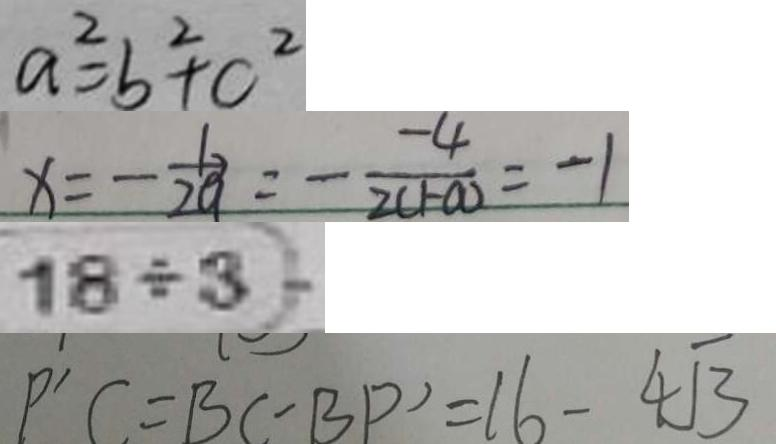<formula> <loc_0><loc_0><loc_500><loc_500>a ^ { 2 } = b ^ { 2 } + c ^ { 2 } 
 x = - \frac { b } { 2 a } = - \frac { - 4 } { 2 ( 1 - a ) } = - 1 
 1 8 \div 3 = 
 P ^ { \prime } C = B C - B P ^ { \prime } = 1 6 - 4 \sqrt { 3 }</formula> 